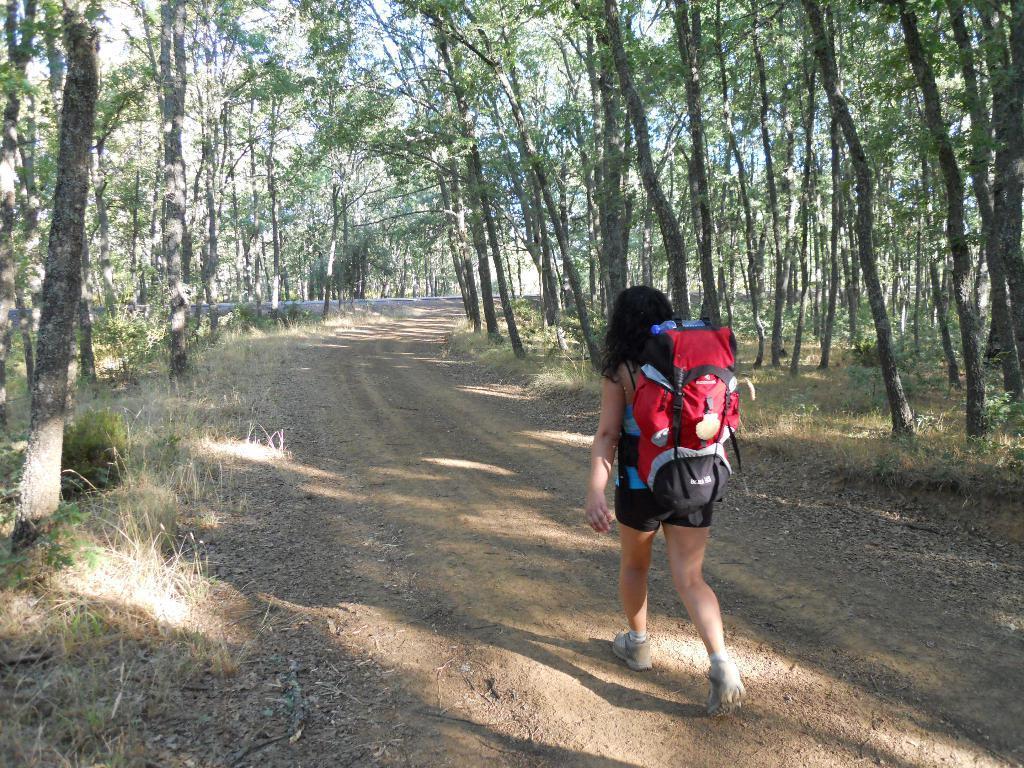In one or two sentences, can you explain what this image depicts? In this picture we can see a woman wearing backpack and walking on the path. Some grass is visible on the ground. There are few trees visible on left and right side of the path. 